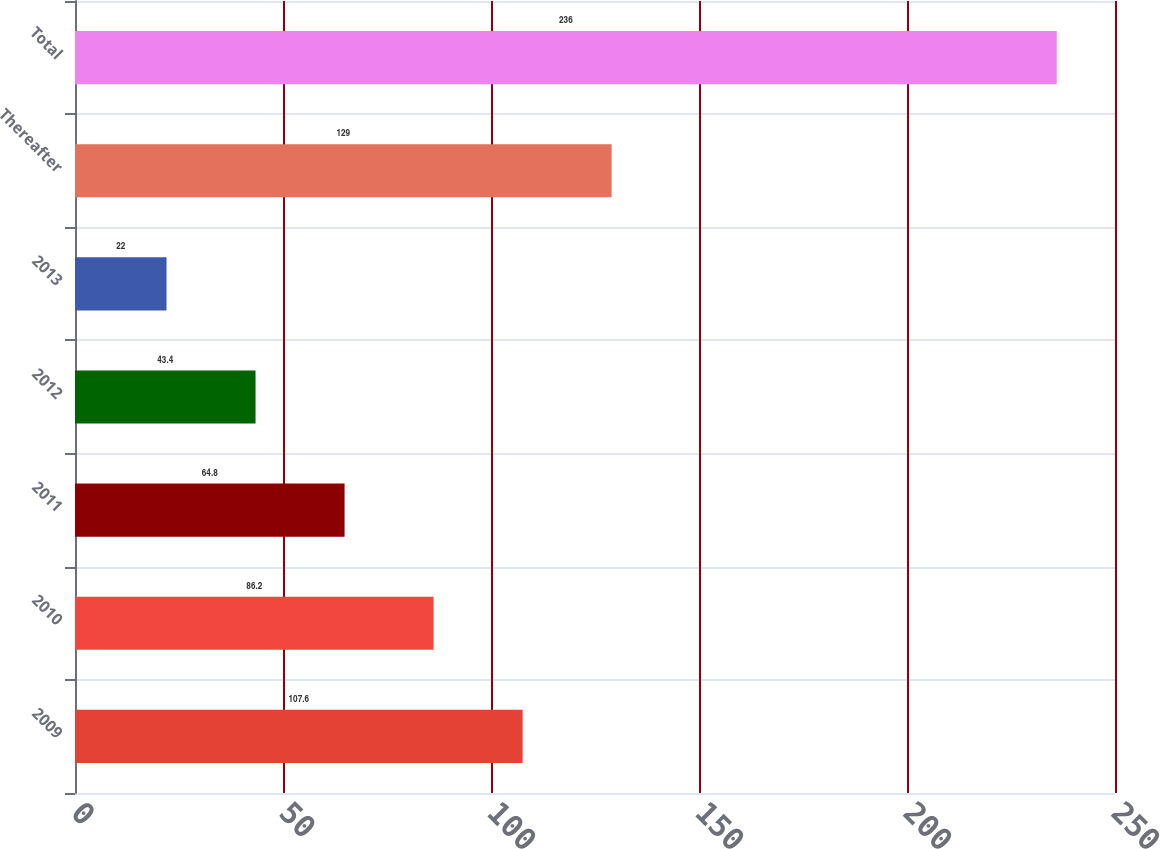Convert chart. <chart><loc_0><loc_0><loc_500><loc_500><bar_chart><fcel>2009<fcel>2010<fcel>2011<fcel>2012<fcel>2013<fcel>Thereafter<fcel>Total<nl><fcel>107.6<fcel>86.2<fcel>64.8<fcel>43.4<fcel>22<fcel>129<fcel>236<nl></chart> 